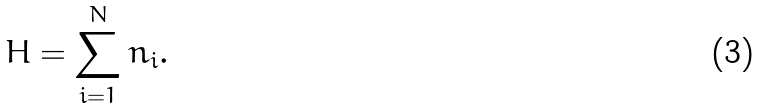Convert formula to latex. <formula><loc_0><loc_0><loc_500><loc_500>H = \sum _ { i = 1 } ^ { N } n _ { i } .</formula> 